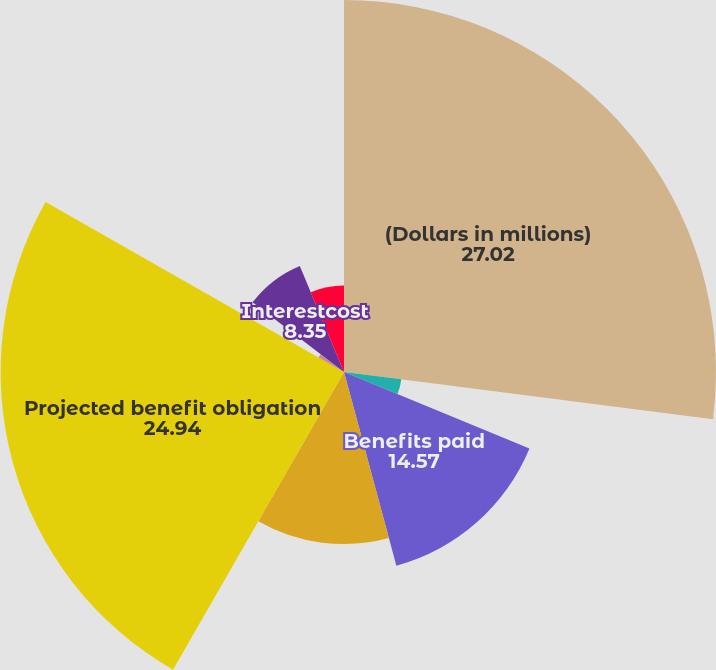Convert chart. <chart><loc_0><loc_0><loc_500><loc_500><pie_chart><fcel>(Dollars in millions)<fcel>Company contributions (2)<fcel>Benefits paid<fcel>Fair value December 31<fcel>Projected benefit obligation<fcel>Servicecost<fcel>Interestcost<fcel>Actuarialloss<nl><fcel>27.02%<fcel>4.2%<fcel>14.57%<fcel>12.5%<fcel>24.94%<fcel>2.13%<fcel>8.35%<fcel>6.28%<nl></chart> 